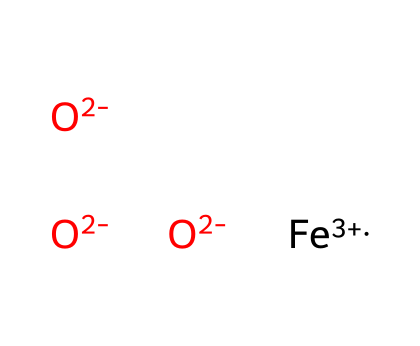What is the oxidation state of iron in this compound? The chemical composition includes [Fe+3], indicating that iron is in the +3 oxidation state. The oxidation state refers to the charge of the metal ion in this compound.
Answer: +3 How many oxygen atoms are in the chemical? The chemical contains three instances of [O-2], meaning there are three oxygen atoms present. Each [O-2] represents one oxygen atom, so counting them results in three.
Answer: 3 What is the overall charge of this iron oxide? The charges can be summed as follows: +3 from iron and -2 from each of the three oxygen atoms (3 * -2 = -6). Therefore, the total charge is +3 - 6 = -3.
Answer: -3 What type of metal is represented in this compound? The element represented by [Fe] is iron, which is a transition metal and is characterized by its ability to form colored compounds and oxides.
Answer: transition metal Are there any metallic bonds present in this iron oxide? This compound is an ionic compound formed by the electrostatic forces between the metal cation (iron) and the anions (oxygen), indicating it does not involve metallic bonding typical of metals.
Answer: no What is the primary use of iron oxide pigments? Iron oxide pigments, such as the one represented here, are predominantly used for coloring and providing pigment in various applications, including traditional body painting and art.
Answer: coloring 